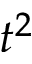<formula> <loc_0><loc_0><loc_500><loc_500>t ^ { 2 }</formula> 